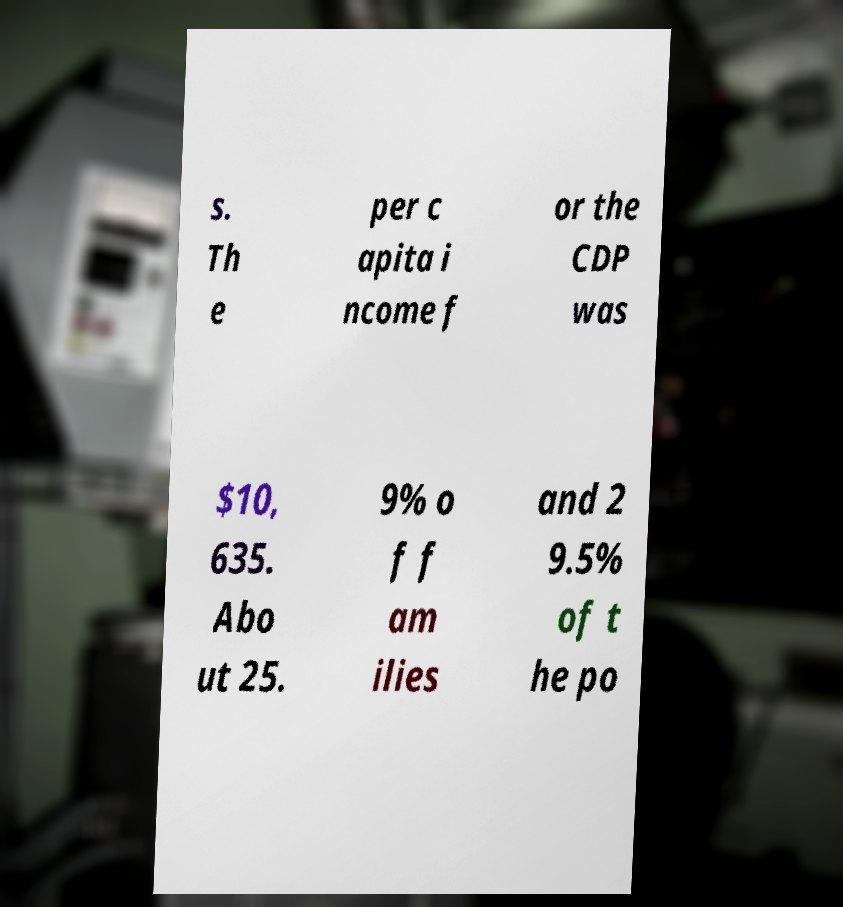Could you assist in decoding the text presented in this image and type it out clearly? s. Th e per c apita i ncome f or the CDP was $10, 635. Abo ut 25. 9% o f f am ilies and 2 9.5% of t he po 